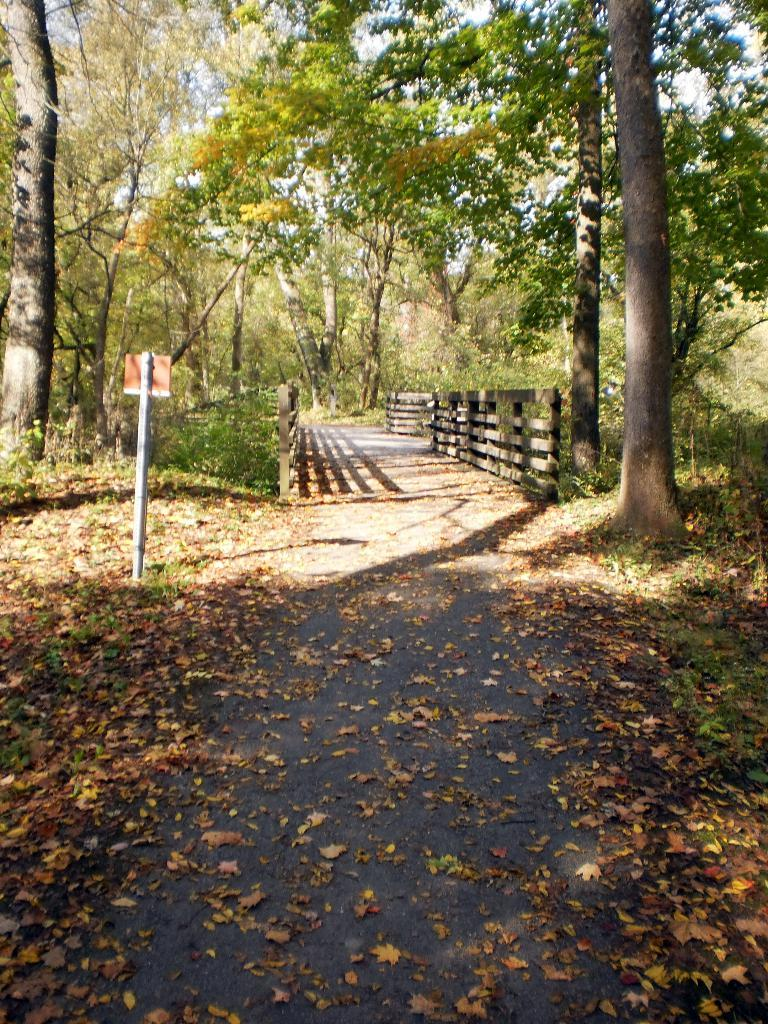What can be seen in the center of the image? The sky is visible in the center of the image. What type of vegetation is present in the image? There are trees and grass in the image. What other objects can be found on the ground? Dry leaves are in the image. Are there any structures or boundaries in the image? Yes, there are fences in the image. What type of pathway is visible in the image? A walkway is visible in the image. What is attached to the pole in the image? There is a pole with a board in the image. How many books can be seen on the ant in the image? There are no ants or books present in the image. What type of rabbit is hiding behind the trees in the image? There are no rabbits present in the image. 